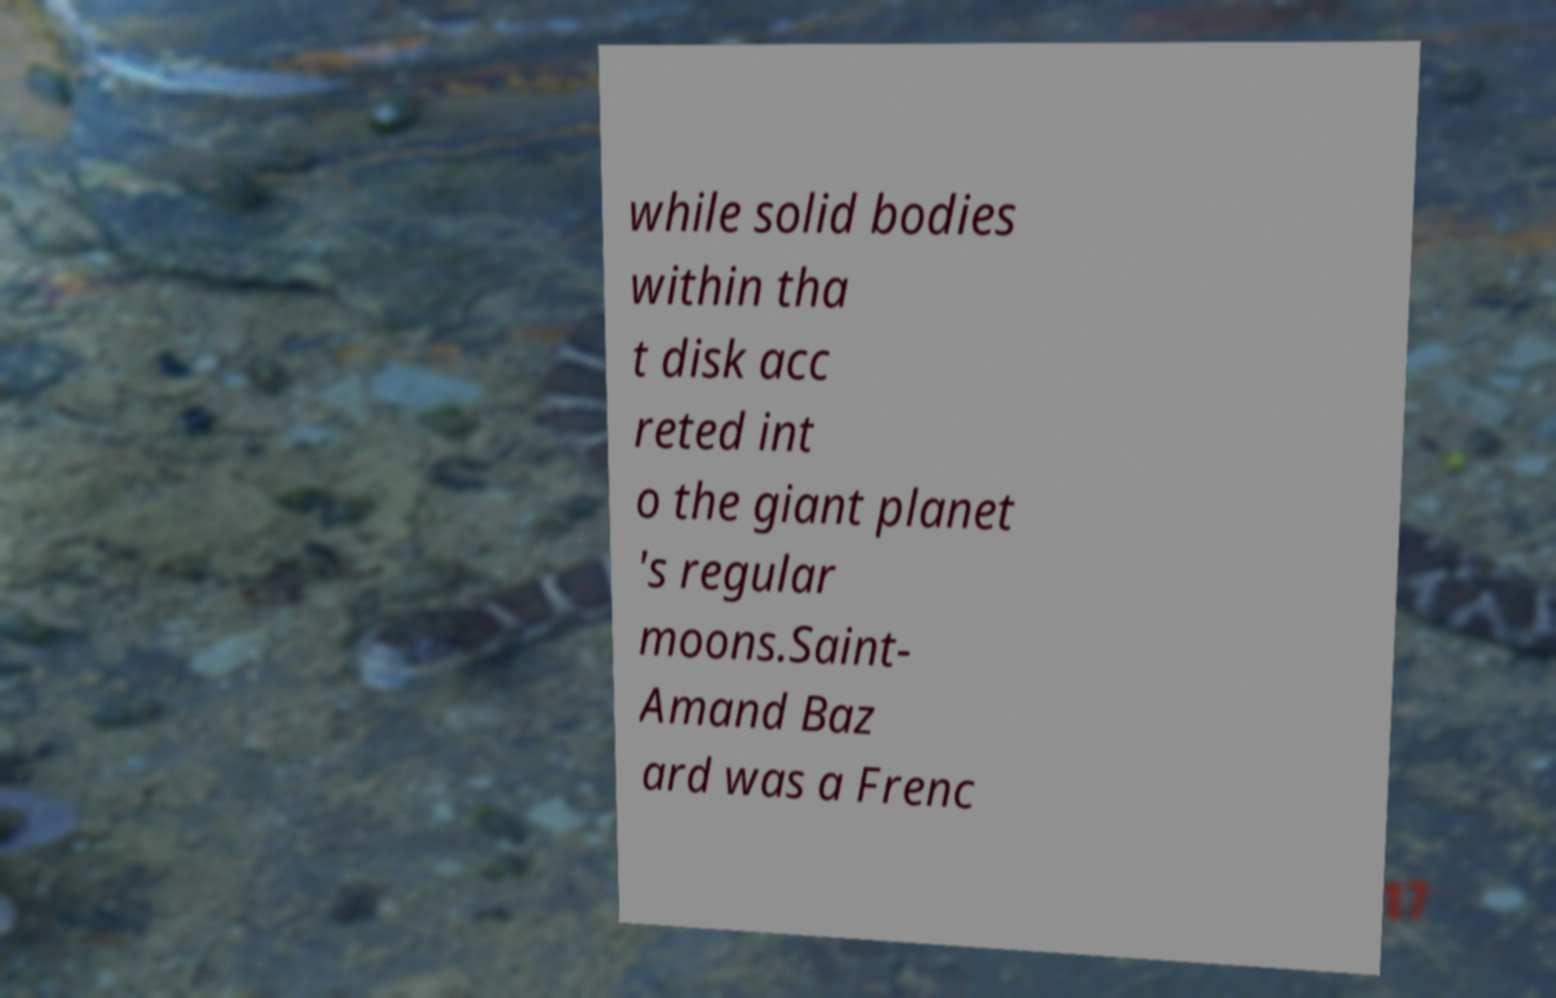There's text embedded in this image that I need extracted. Can you transcribe it verbatim? while solid bodies within tha t disk acc reted int o the giant planet 's regular moons.Saint- Amand Baz ard was a Frenc 